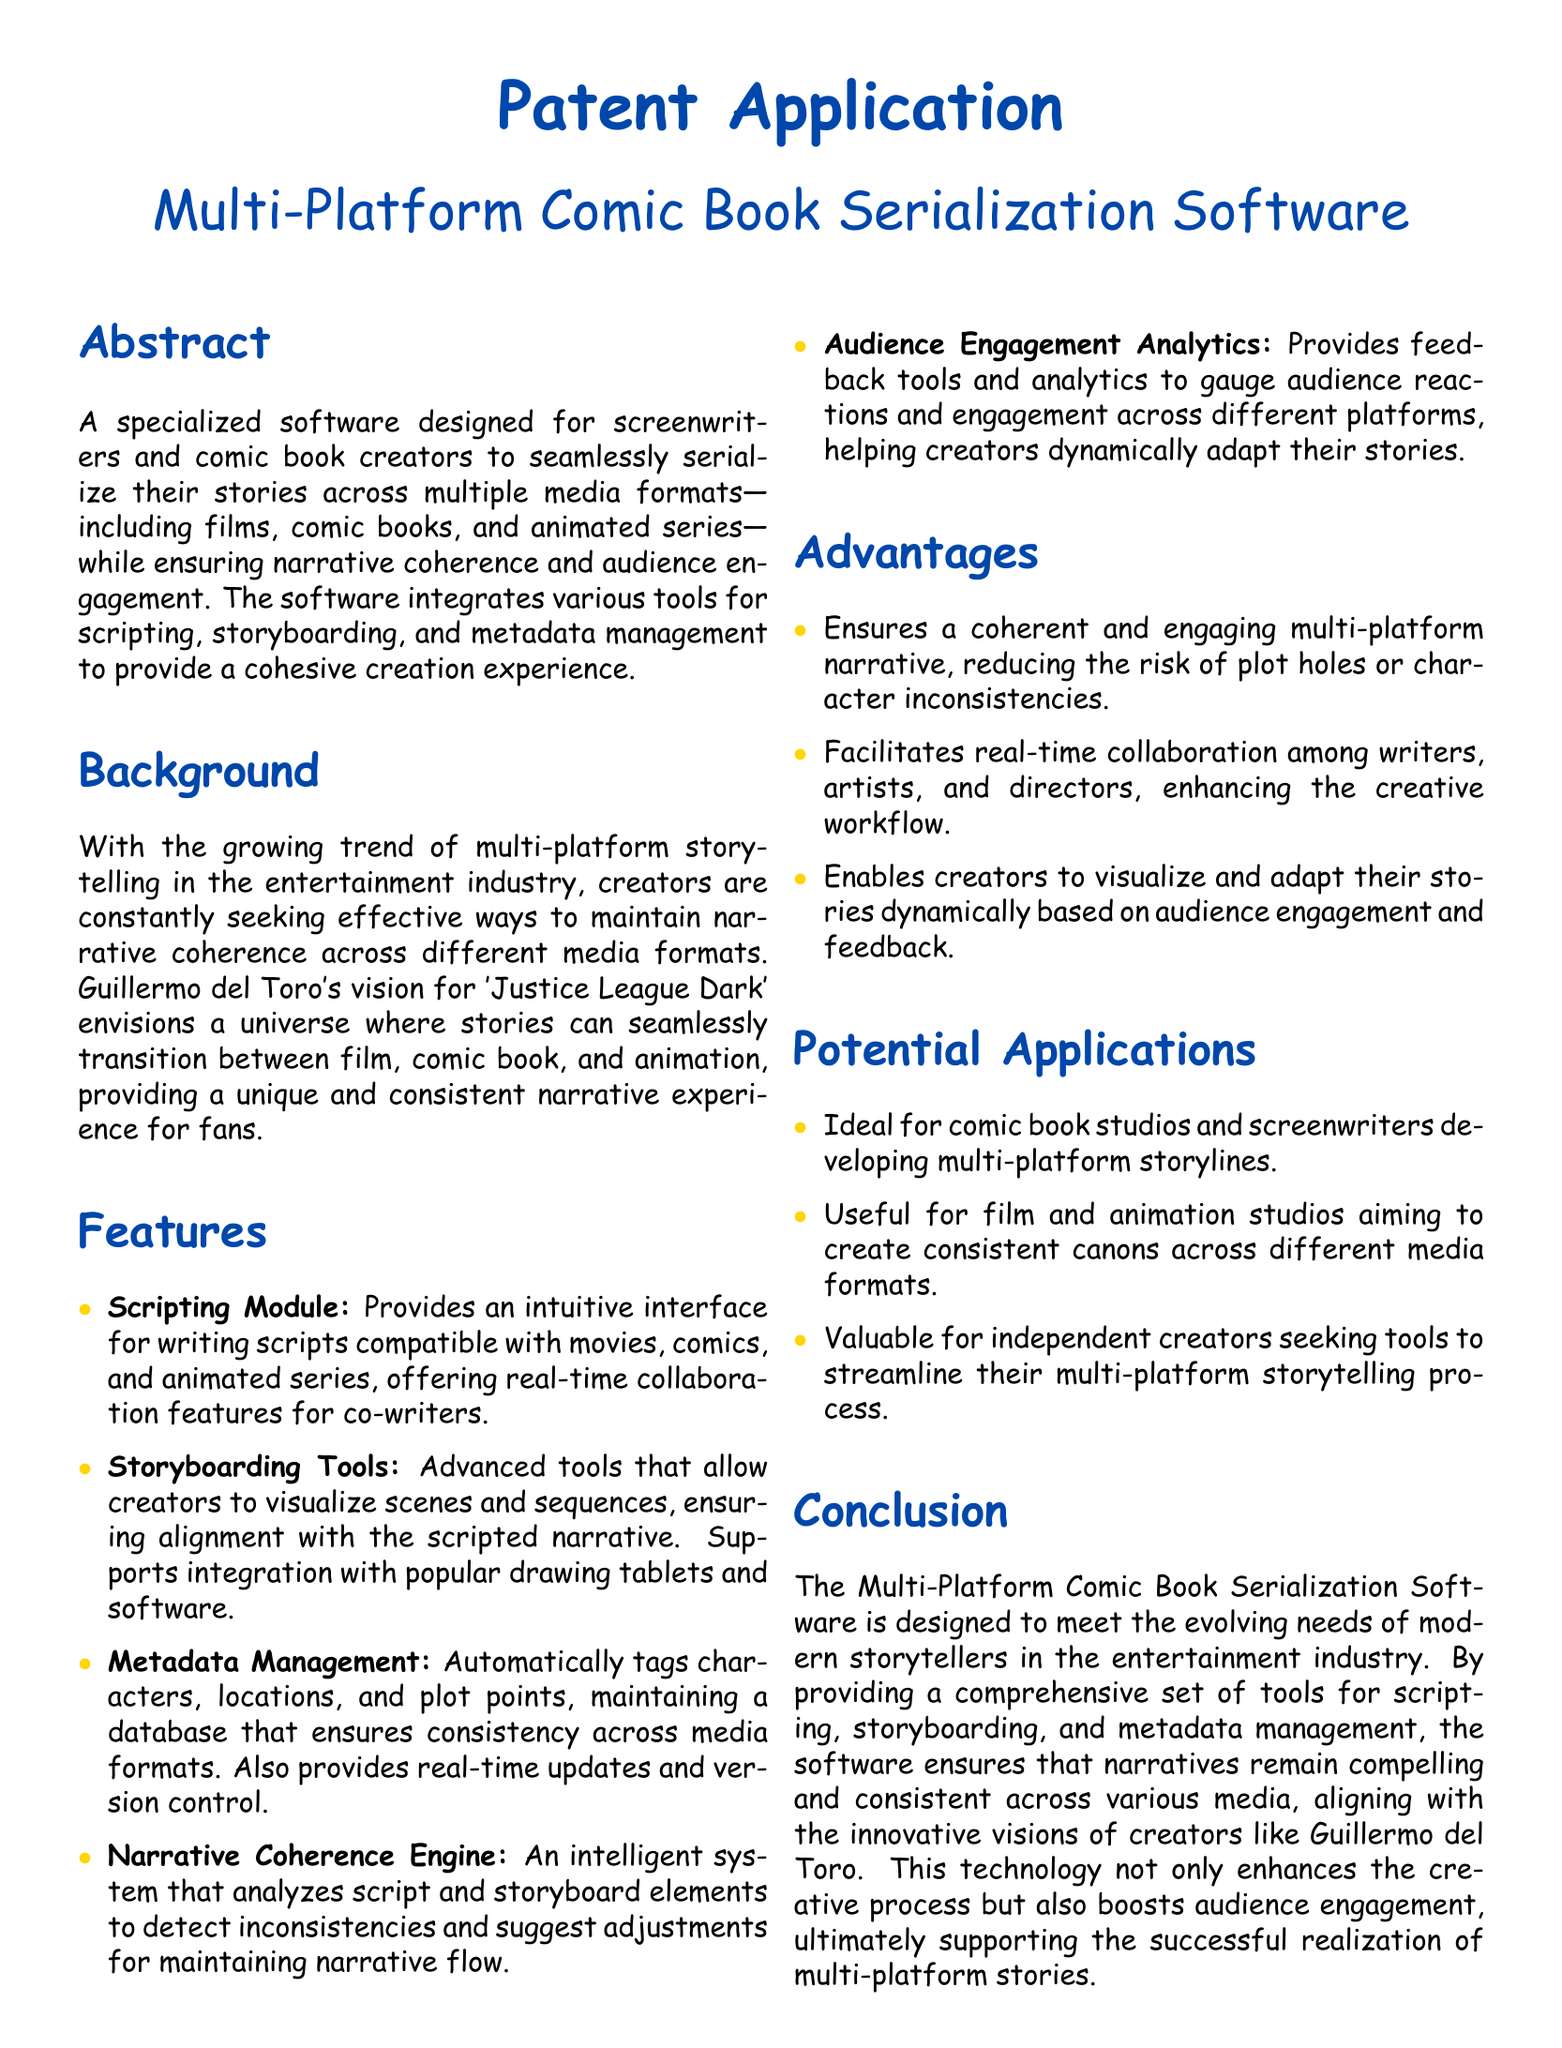What is the title of the software? The title of the software is stated at the beginning of the document.
Answer: Multi-Platform Comic Book Serialization Software Who is the intended user of the software? The document highlights the main users of the software in the abstract section.
Answer: Screenwriters and comic book creators What is one feature of the Scripting Module? A specific feature of the Scripting Module is mentioned in the features section.
Answer: Intuitive interface What does the Narrative Coherence Engine do? The function of the Narrative Coherence Engine is summarized in the features section.
Answer: Analyzes script and storyboard elements What type of analytics does the software provide? The document outlines the type of analytics offered in the Audience Engagement Analytics feature.
Answer: Feedback tools and analytics Which creator's vision is mentioned in the background? The background section references a well-known creator associated with multi-platform storytelling.
Answer: Guillermo del Toro What is one potential application of the software? Potential applications are listed in the respective section.
Answer: Comic book studios How does the software enhance creative workflow? The advantages section explains how the software improves creative processes.
Answer: Facilitates real-time collaboration What major need does the software address? The conclusion highlights a primary need that the software fulfills for modern storytellers.
Answer: Multi-platform storytelling 